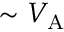Convert formula to latex. <formula><loc_0><loc_0><loc_500><loc_500>\sim { V _ { A } }</formula> 